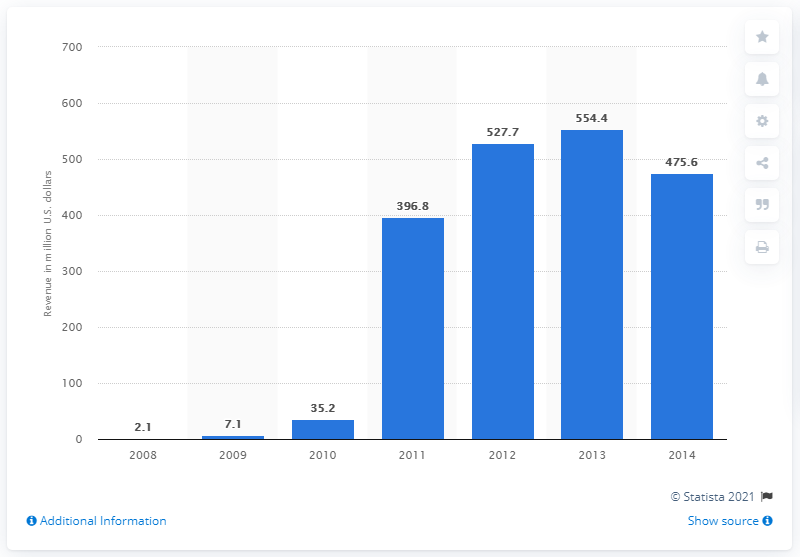Mention a couple of crucial points in this snapshot. In 2009, Molycorp reported a revenue of 7.1 billion dollars. 